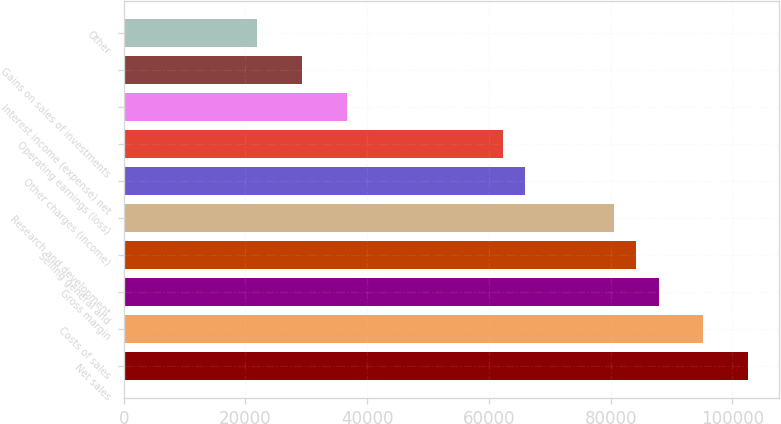Convert chart. <chart><loc_0><loc_0><loc_500><loc_500><bar_chart><fcel>Net sales<fcel>Costs of sales<fcel>Gross margin<fcel>Selling general and<fcel>Research and development<fcel>Other charges (income)<fcel>Operating earnings (loss)<fcel>Interest income (expense) net<fcel>Gains on sales of investments<fcel>Other<nl><fcel>102542<fcel>95217.2<fcel>87892.8<fcel>84230.6<fcel>80568.4<fcel>65919.6<fcel>62257.4<fcel>36622<fcel>29297.6<fcel>21973.2<nl></chart> 